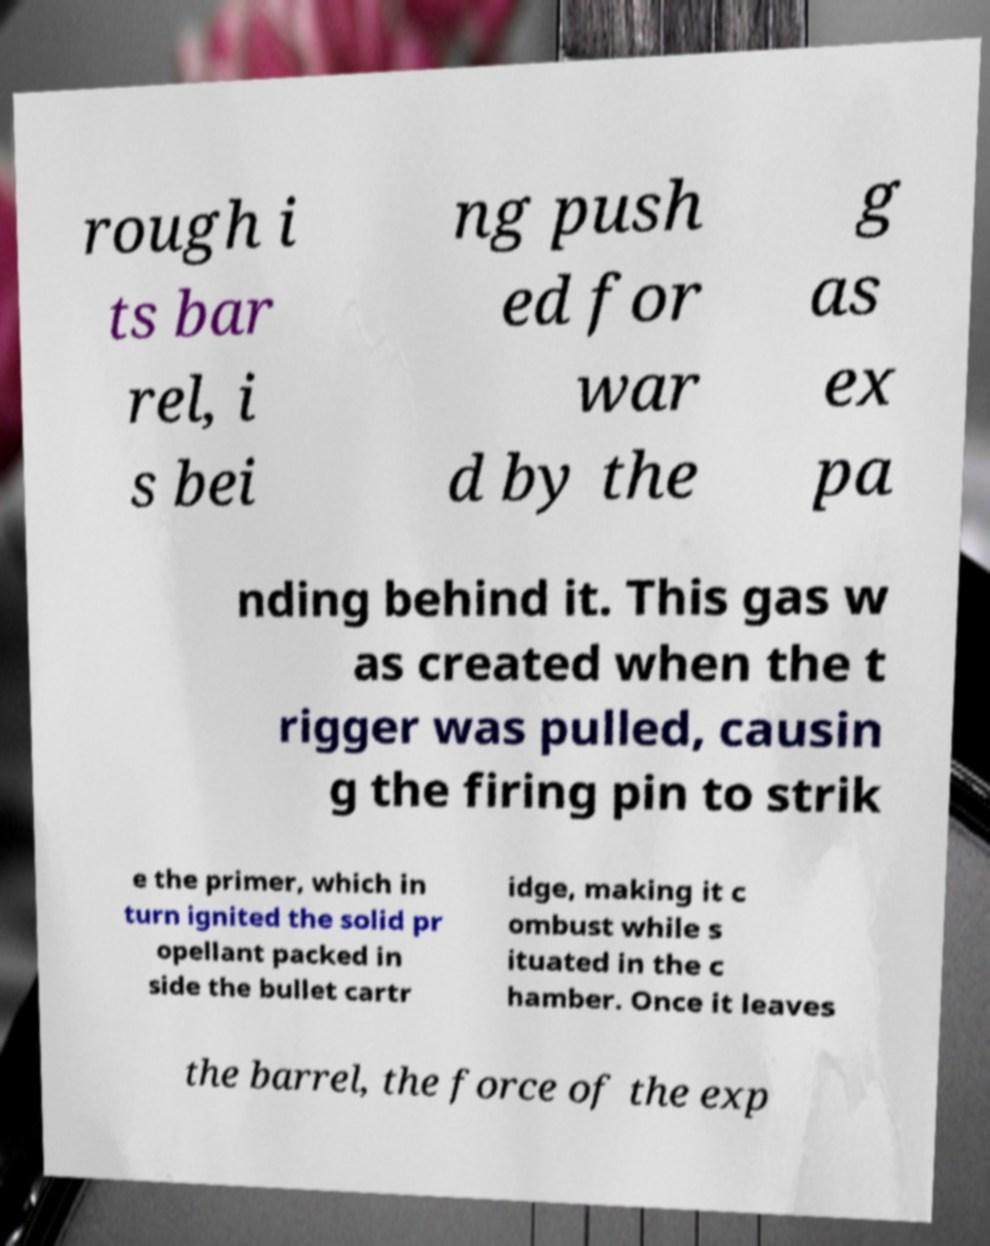Could you assist in decoding the text presented in this image and type it out clearly? rough i ts bar rel, i s bei ng push ed for war d by the g as ex pa nding behind it. This gas w as created when the t rigger was pulled, causin g the firing pin to strik e the primer, which in turn ignited the solid pr opellant packed in side the bullet cartr idge, making it c ombust while s ituated in the c hamber. Once it leaves the barrel, the force of the exp 